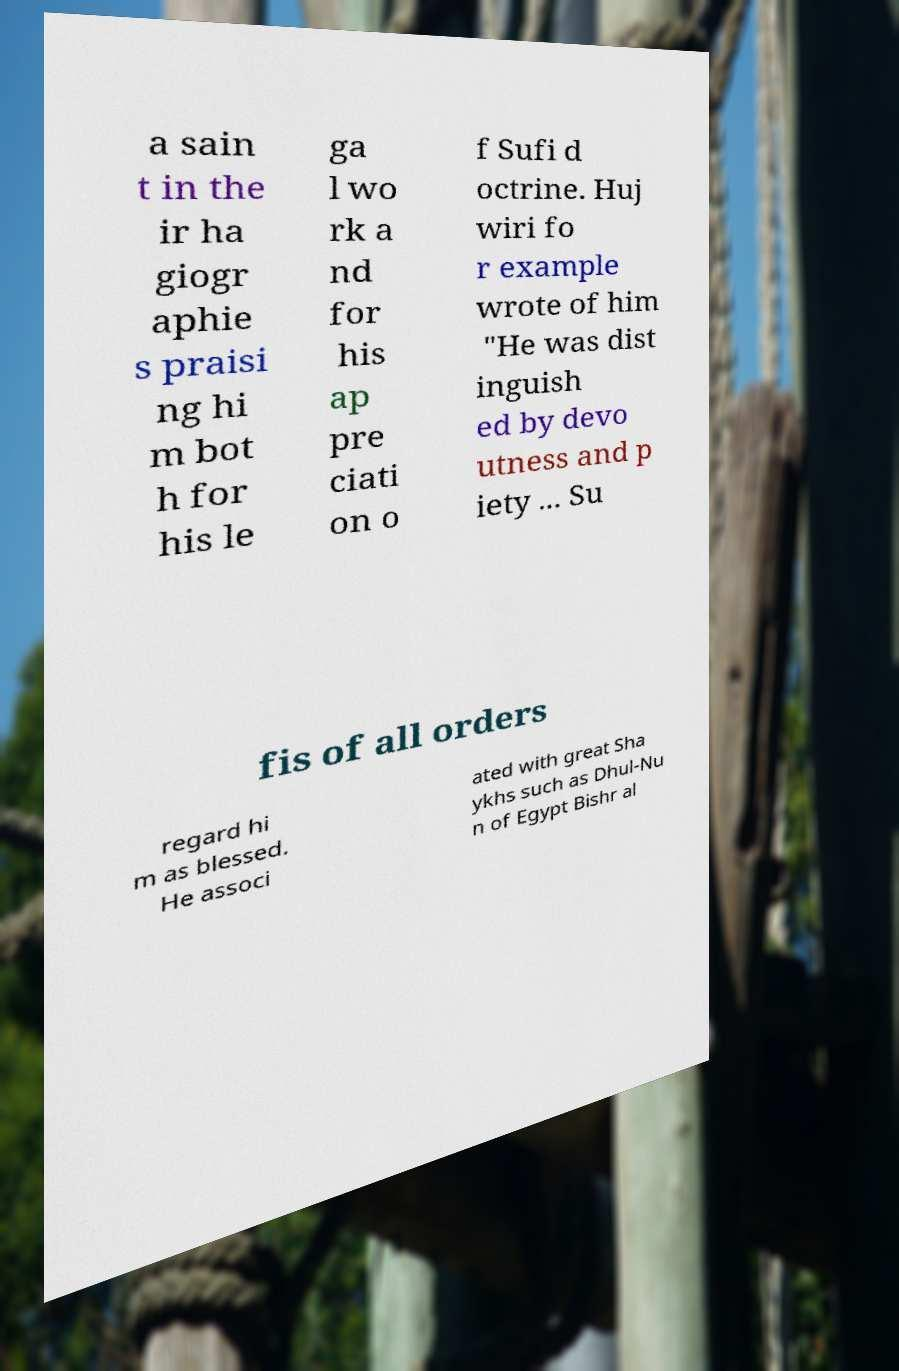Can you accurately transcribe the text from the provided image for me? a sain t in the ir ha giogr aphie s praisi ng hi m bot h for his le ga l wo rk a nd for his ap pre ciati on o f Sufi d octrine. Huj wiri fo r example wrote of him "He was dist inguish ed by devo utness and p iety ... Su fis of all orders regard hi m as blessed. He associ ated with great Sha ykhs such as Dhul-Nu n of Egypt Bishr al 